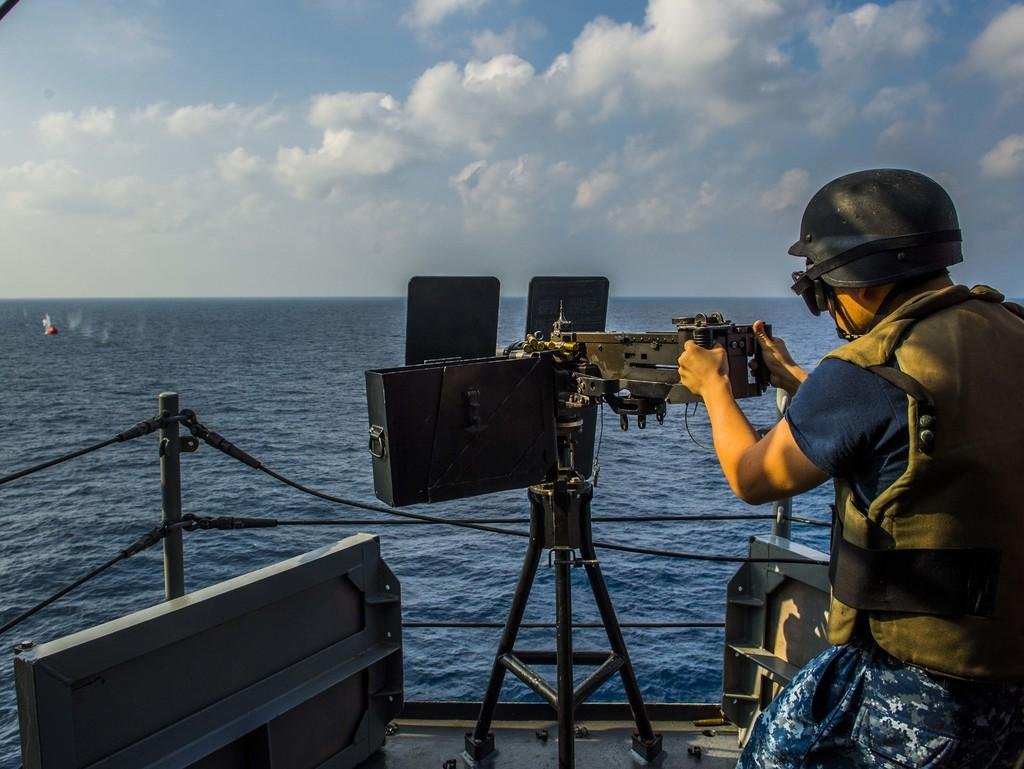What is the main subject of the image? There is a person in the image. What is the person holding in the image? The person is holding a machine gun. Where is the person located in the image? The person is on a ship. What can be seen in the background of the image? There is sea and sky visible in the background of the image. What is the condition of the sky in the image? There are clouds in the sky. What type of cap is the person wearing in the image? There is no cap visible in the image; the person is not wearing one. Can you read the note that the person is holding in the image? There is no note present in the image; the person is holding a machine gun. 